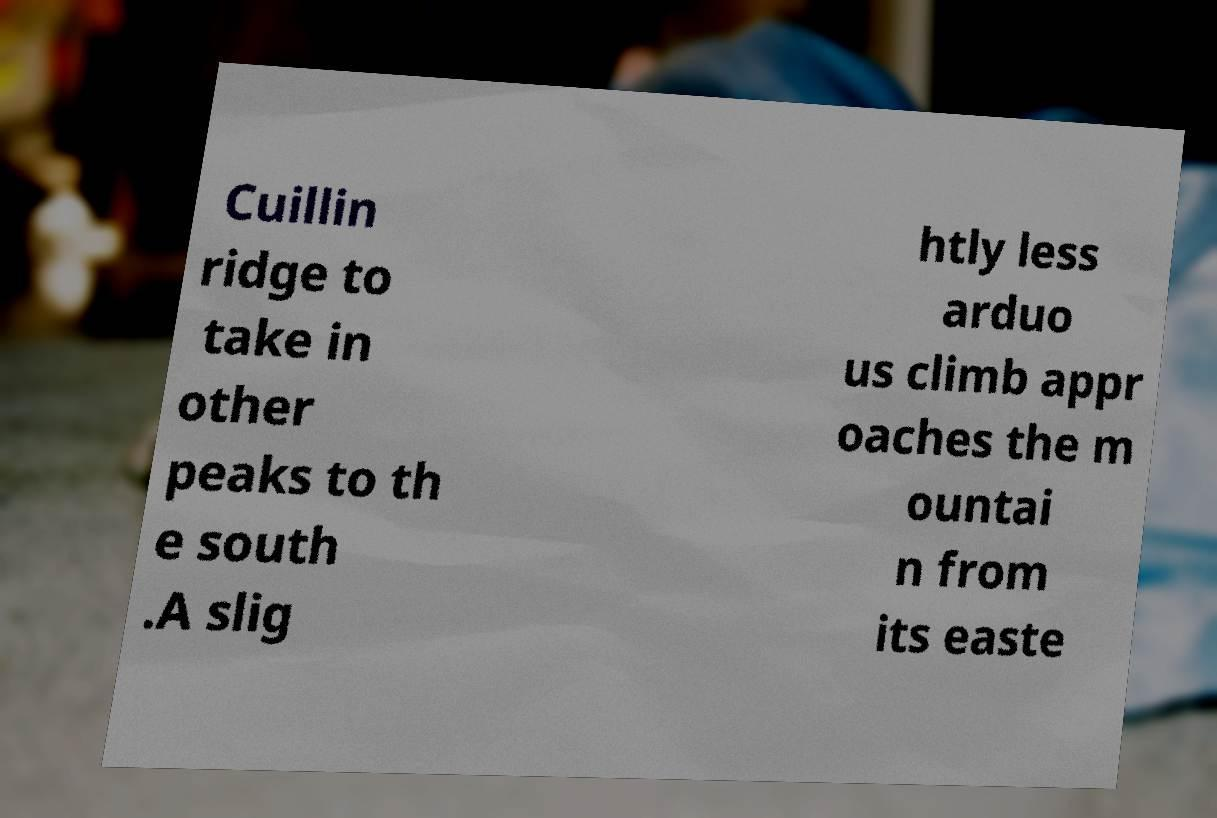Can you accurately transcribe the text from the provided image for me? Cuillin ridge to take in other peaks to th e south .A slig htly less arduo us climb appr oaches the m ountai n from its easte 